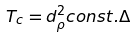Convert formula to latex. <formula><loc_0><loc_0><loc_500><loc_500>T _ { c } = d ^ { 2 } _ { \rho } c o n s t . \Delta</formula> 